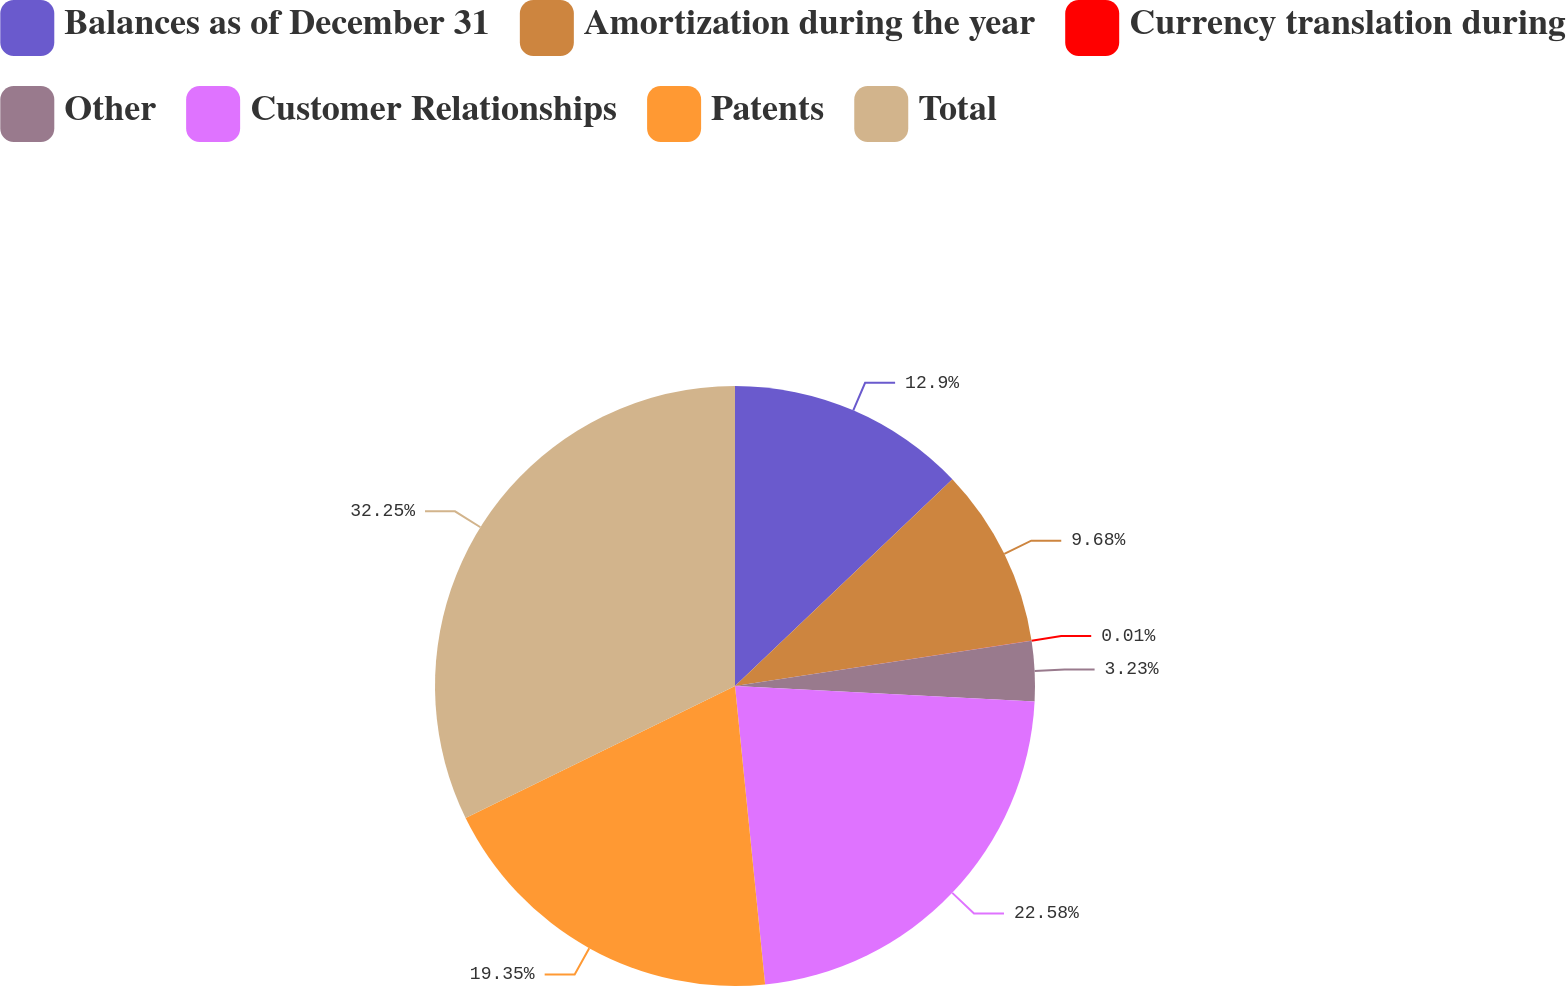Convert chart to OTSL. <chart><loc_0><loc_0><loc_500><loc_500><pie_chart><fcel>Balances as of December 31<fcel>Amortization during the year<fcel>Currency translation during<fcel>Other<fcel>Customer Relationships<fcel>Patents<fcel>Total<nl><fcel>12.9%<fcel>9.68%<fcel>0.01%<fcel>3.23%<fcel>22.58%<fcel>19.35%<fcel>32.25%<nl></chart> 